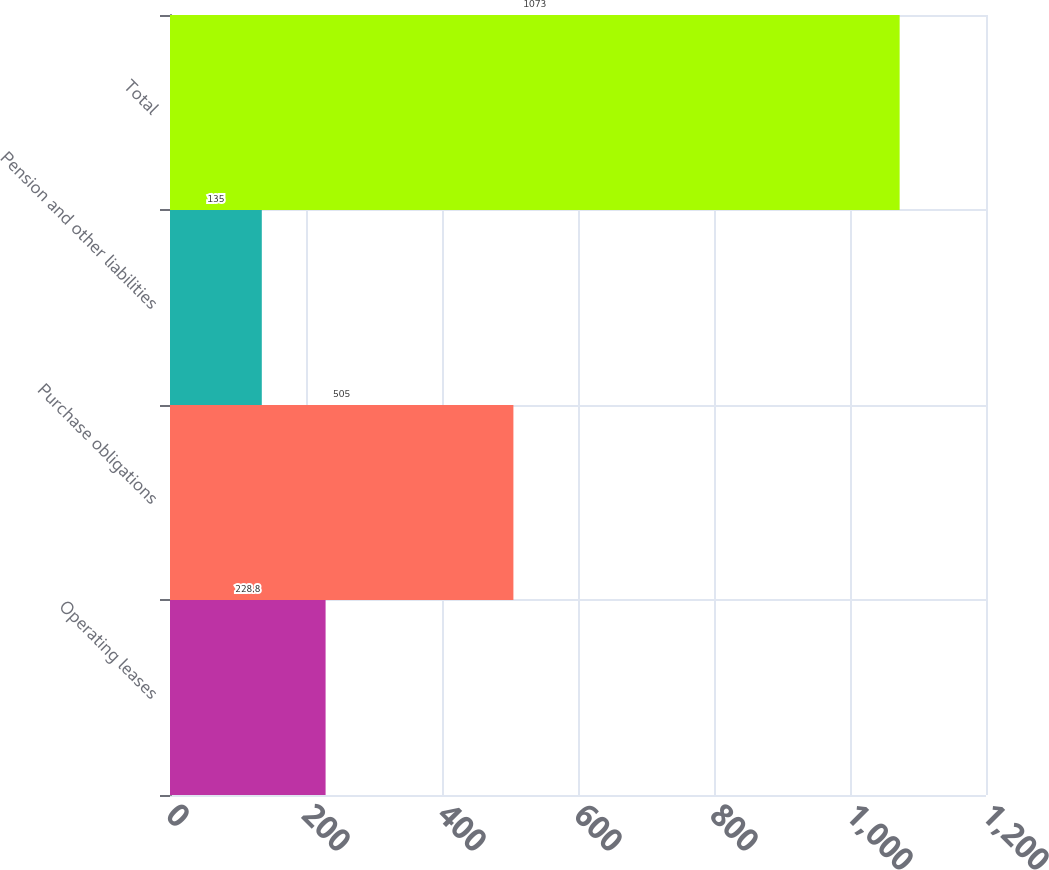Convert chart. <chart><loc_0><loc_0><loc_500><loc_500><bar_chart><fcel>Operating leases<fcel>Purchase obligations<fcel>Pension and other liabilities<fcel>Total<nl><fcel>228.8<fcel>505<fcel>135<fcel>1073<nl></chart> 